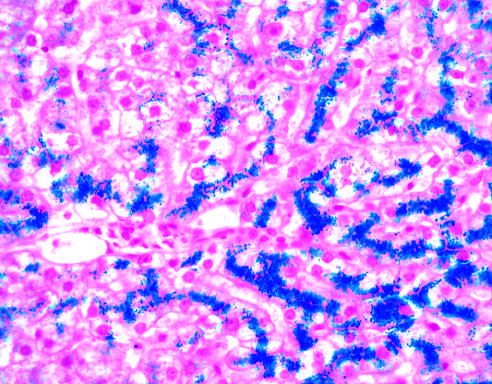does hepatocellular iron appear blue in this prussian blue-stained section?
Answer the question using a single word or phrase. Yes 